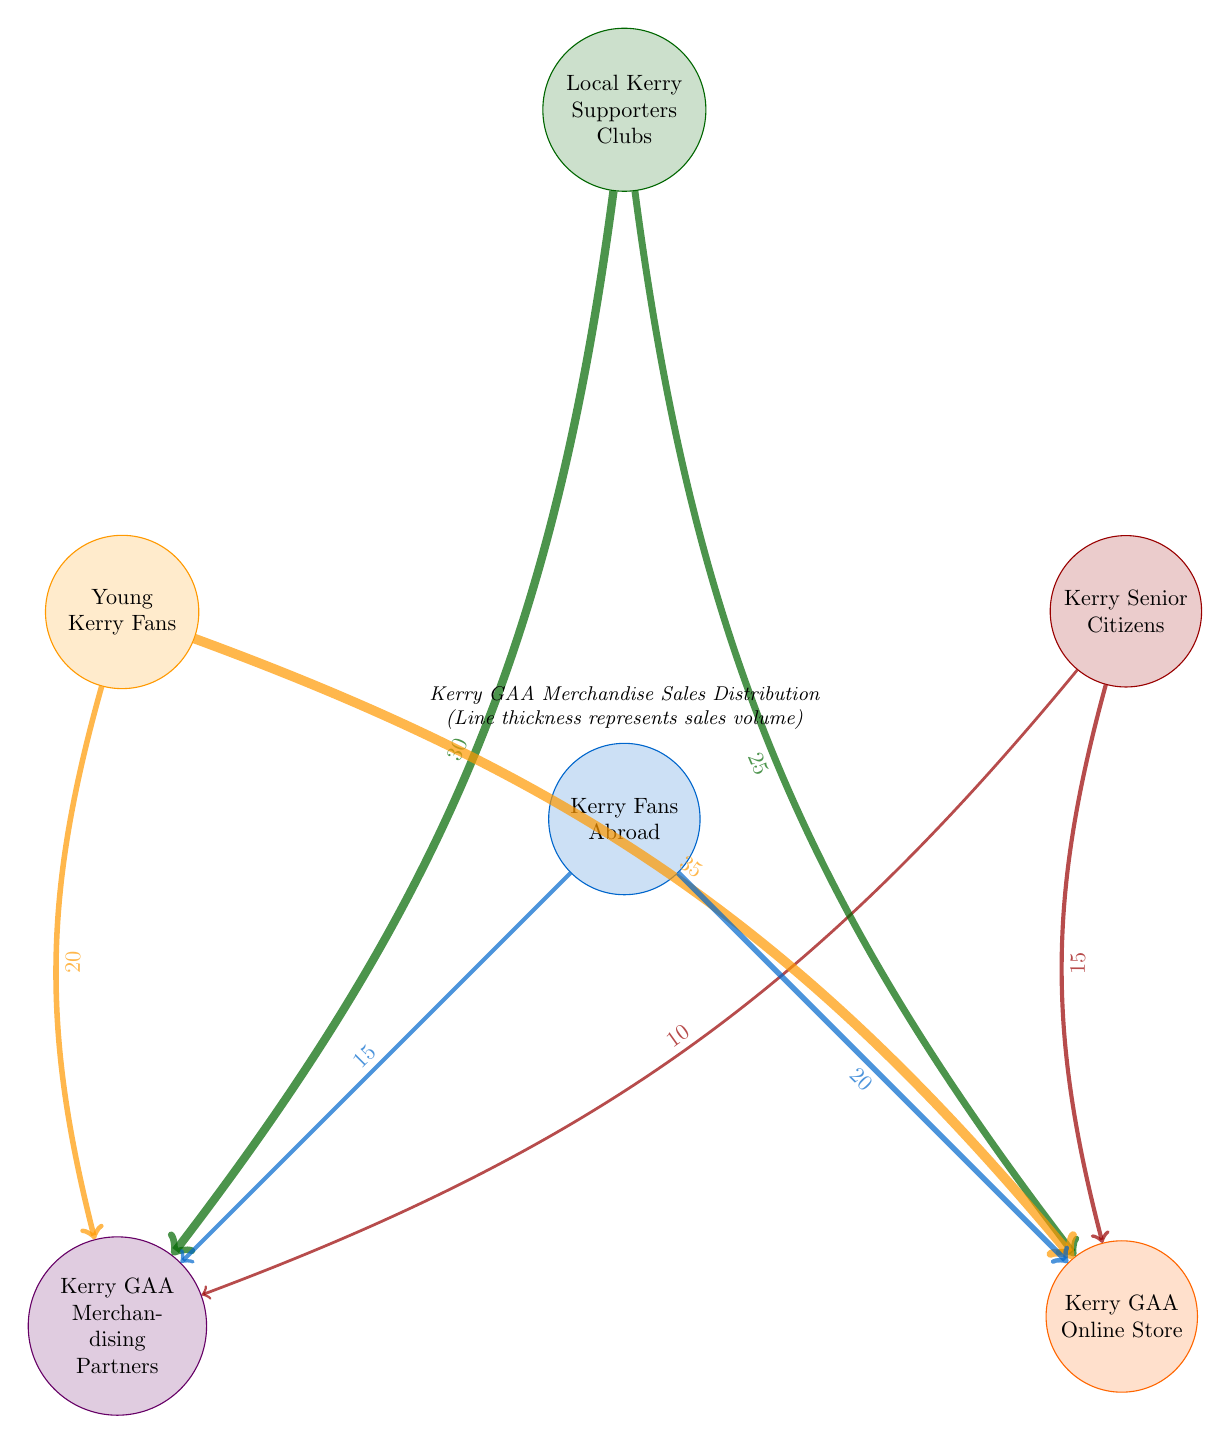What is the total sales value from Local Kerry Supporters Clubs to Kerry GAA Merchandising Partners? The link from Local Kerry Supporters Clubs to Kerry GAA Merchandising Partners shows a value of 30, indicating this is the total sales value.
Answer: 30 How many nodes are in the diagram? The diagram has six nodes: Local Kerry Supporters Clubs, Young Kerry Fans, Kerry Senior Citizens, Kerry Fans Abroad, Kerry GAA Merchandising Partners, and Kerry GAA Online Store. Thus, the total is 6 nodes.
Answer: 6 Which group has the highest sales to the Kerry GAA Online Store? The link from Young Kerry Fans to Kerry GAA Online Store has the highest value of 35, making them the group with the highest sales to that node.
Answer: Young Kerry Fans What is the total value of sales from Kerry Senior Citizens? The sales value from Kerry Senior Citizens to Kerry GAA Merchandising Partners is 10 and to Kerry GAA Online Store is 15. Adding these gives a total of 10 + 15 = 25.
Answer: 25 Who contributes more to the Kerry GAA Merchandising Partners: Local Kerry Supporters Clubs or Kerry Fans Abroad? Local Kerry Supporters Clubs contribute 30, while Kerry Fans Abroad contribute 15. Since 30 is greater than 15, Local Kerry Supporters Clubs contribute more.
Answer: Local Kerry Supporters Clubs What is the combined sales value from Young Kerry Fans to both merchandising nodes? The sales value from Young Kerry Fans to Kerry GAA Merchandising Partners is 20, and to Kerry GAA Online Store, it is 35. Thus, the combined value is 20 + 35 = 55.
Answer: 55 Which fan group has the least sales to Kerry GAA Merchandising Partners? The least sales value shown for Kerry GAA Merchandising Partners is 10 from Kerry Senior Citizens, making them the group with the least sales to this node.
Answer: Kerry Senior Citizens What is the total sales value from all groups to the Kerry GAA Online Store? The total sales value to the Kerry GAA Online Store includes 25 from Local Kerry Supporters Clubs, 35 from Young Kerry Fans, 15 from Kerry Senior Citizens, and 20 from Kerry Fans Abroad. Thus, 25 + 35 + 15 + 20 = 95.
Answer: 95 